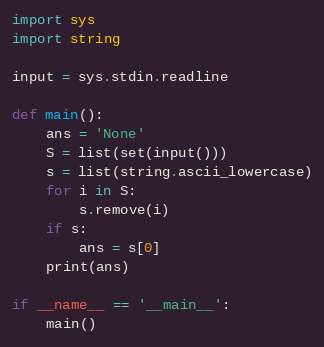<code> <loc_0><loc_0><loc_500><loc_500><_Python_>import sys
import string

input = sys.stdin.readline

def main():
    ans = 'None'
    S = list(set(input()))
    s = list(string.ascii_lowercase)
    for i in S:
        s.remove(i)
    if s:
        ans = s[0]
    print(ans)

if __name__ == '__main__':
    main()</code> 